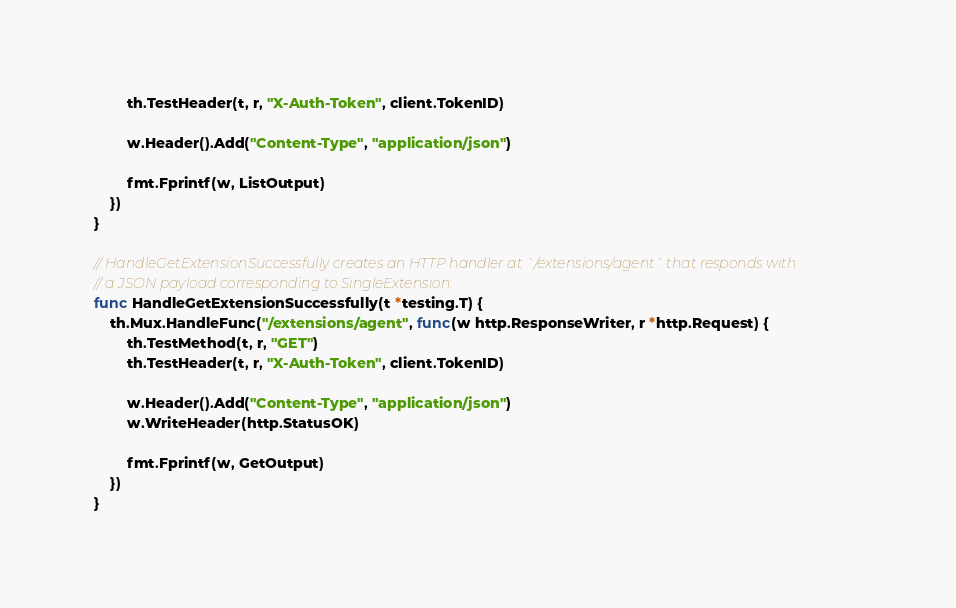<code> <loc_0><loc_0><loc_500><loc_500><_Go_>		th.TestHeader(t, r, "X-Auth-Token", client.TokenID)

		w.Header().Add("Content-Type", "application/json")

		fmt.Fprintf(w, ListOutput)
	})
}

// HandleGetExtensionSuccessfully creates an HTTP handler at `/extensions/agent` that responds with
// a JSON payload corresponding to SingleExtension.
func HandleGetExtensionSuccessfully(t *testing.T) {
	th.Mux.HandleFunc("/extensions/agent", func(w http.ResponseWriter, r *http.Request) {
		th.TestMethod(t, r, "GET")
		th.TestHeader(t, r, "X-Auth-Token", client.TokenID)

		w.Header().Add("Content-Type", "application/json")
		w.WriteHeader(http.StatusOK)

		fmt.Fprintf(w, GetOutput)
	})
}
</code> 